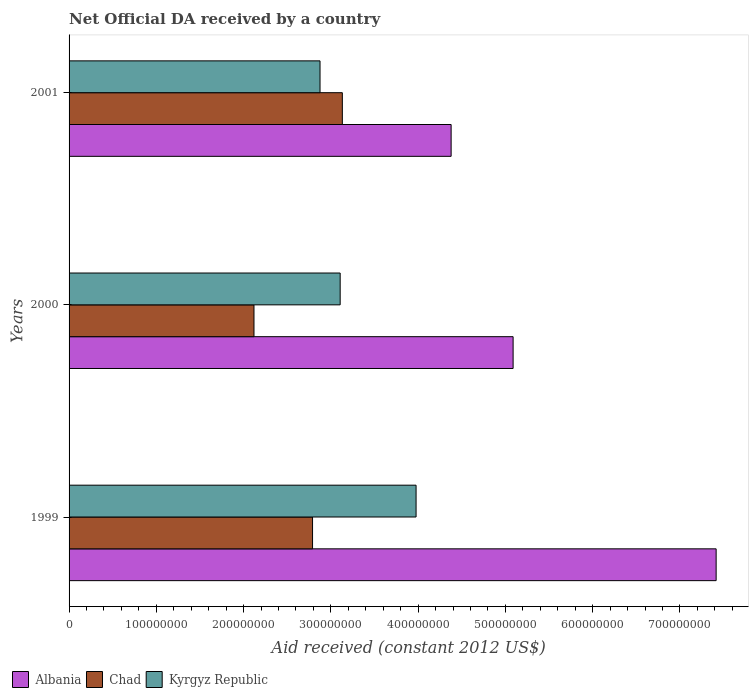How many different coloured bars are there?
Make the answer very short. 3. Are the number of bars per tick equal to the number of legend labels?
Ensure brevity in your answer.  Yes. Are the number of bars on each tick of the Y-axis equal?
Give a very brief answer. Yes. How many bars are there on the 1st tick from the bottom?
Offer a very short reply. 3. What is the net official development assistance aid received in Kyrgyz Republic in 2001?
Offer a terse response. 2.88e+08. Across all years, what is the maximum net official development assistance aid received in Albania?
Make the answer very short. 7.41e+08. Across all years, what is the minimum net official development assistance aid received in Kyrgyz Republic?
Ensure brevity in your answer.  2.88e+08. In which year was the net official development assistance aid received in Albania maximum?
Your response must be concise. 1999. In which year was the net official development assistance aid received in Albania minimum?
Your response must be concise. 2001. What is the total net official development assistance aid received in Albania in the graph?
Provide a succinct answer. 1.69e+09. What is the difference between the net official development assistance aid received in Chad in 1999 and that in 2001?
Your answer should be very brief. -3.41e+07. What is the difference between the net official development assistance aid received in Albania in 2000 and the net official development assistance aid received in Kyrgyz Republic in 2001?
Offer a very short reply. 2.21e+08. What is the average net official development assistance aid received in Kyrgyz Republic per year?
Your answer should be very brief. 3.32e+08. In the year 2000, what is the difference between the net official development assistance aid received in Albania and net official development assistance aid received in Kyrgyz Republic?
Offer a terse response. 1.98e+08. What is the ratio of the net official development assistance aid received in Kyrgyz Republic in 1999 to that in 2001?
Make the answer very short. 1.38. Is the difference between the net official development assistance aid received in Albania in 1999 and 2000 greater than the difference between the net official development assistance aid received in Kyrgyz Republic in 1999 and 2000?
Give a very brief answer. Yes. What is the difference between the highest and the second highest net official development assistance aid received in Kyrgyz Republic?
Give a very brief answer. 8.70e+07. What is the difference between the highest and the lowest net official development assistance aid received in Chad?
Offer a very short reply. 1.01e+08. In how many years, is the net official development assistance aid received in Chad greater than the average net official development assistance aid received in Chad taken over all years?
Provide a short and direct response. 2. Is the sum of the net official development assistance aid received in Albania in 2000 and 2001 greater than the maximum net official development assistance aid received in Chad across all years?
Keep it short and to the point. Yes. What does the 3rd bar from the top in 1999 represents?
Ensure brevity in your answer.  Albania. What does the 3rd bar from the bottom in 1999 represents?
Provide a short and direct response. Kyrgyz Republic. How many bars are there?
Give a very brief answer. 9. Are all the bars in the graph horizontal?
Your response must be concise. Yes. How many years are there in the graph?
Offer a very short reply. 3. Are the values on the major ticks of X-axis written in scientific E-notation?
Provide a short and direct response. No. How many legend labels are there?
Provide a short and direct response. 3. How are the legend labels stacked?
Your response must be concise. Horizontal. What is the title of the graph?
Offer a very short reply. Net Official DA received by a country. Does "Slovenia" appear as one of the legend labels in the graph?
Keep it short and to the point. No. What is the label or title of the X-axis?
Give a very brief answer. Aid received (constant 2012 US$). What is the Aid received (constant 2012 US$) in Albania in 1999?
Give a very brief answer. 7.41e+08. What is the Aid received (constant 2012 US$) of Chad in 1999?
Provide a short and direct response. 2.79e+08. What is the Aid received (constant 2012 US$) in Kyrgyz Republic in 1999?
Your response must be concise. 3.98e+08. What is the Aid received (constant 2012 US$) in Albania in 2000?
Your answer should be very brief. 5.09e+08. What is the Aid received (constant 2012 US$) in Chad in 2000?
Make the answer very short. 2.12e+08. What is the Aid received (constant 2012 US$) of Kyrgyz Republic in 2000?
Your response must be concise. 3.11e+08. What is the Aid received (constant 2012 US$) in Albania in 2001?
Ensure brevity in your answer.  4.38e+08. What is the Aid received (constant 2012 US$) of Chad in 2001?
Make the answer very short. 3.13e+08. What is the Aid received (constant 2012 US$) in Kyrgyz Republic in 2001?
Make the answer very short. 2.88e+08. Across all years, what is the maximum Aid received (constant 2012 US$) in Albania?
Ensure brevity in your answer.  7.41e+08. Across all years, what is the maximum Aid received (constant 2012 US$) of Chad?
Offer a terse response. 3.13e+08. Across all years, what is the maximum Aid received (constant 2012 US$) of Kyrgyz Republic?
Offer a very short reply. 3.98e+08. Across all years, what is the minimum Aid received (constant 2012 US$) of Albania?
Your answer should be very brief. 4.38e+08. Across all years, what is the minimum Aid received (constant 2012 US$) in Chad?
Offer a very short reply. 2.12e+08. Across all years, what is the minimum Aid received (constant 2012 US$) in Kyrgyz Republic?
Offer a very short reply. 2.88e+08. What is the total Aid received (constant 2012 US$) in Albania in the graph?
Keep it short and to the point. 1.69e+09. What is the total Aid received (constant 2012 US$) in Chad in the graph?
Provide a succinct answer. 8.04e+08. What is the total Aid received (constant 2012 US$) of Kyrgyz Republic in the graph?
Make the answer very short. 9.96e+08. What is the difference between the Aid received (constant 2012 US$) in Albania in 1999 and that in 2000?
Make the answer very short. 2.33e+08. What is the difference between the Aid received (constant 2012 US$) of Chad in 1999 and that in 2000?
Keep it short and to the point. 6.71e+07. What is the difference between the Aid received (constant 2012 US$) of Kyrgyz Republic in 1999 and that in 2000?
Give a very brief answer. 8.70e+07. What is the difference between the Aid received (constant 2012 US$) in Albania in 1999 and that in 2001?
Provide a succinct answer. 3.04e+08. What is the difference between the Aid received (constant 2012 US$) of Chad in 1999 and that in 2001?
Your answer should be compact. -3.41e+07. What is the difference between the Aid received (constant 2012 US$) in Kyrgyz Republic in 1999 and that in 2001?
Your response must be concise. 1.10e+08. What is the difference between the Aid received (constant 2012 US$) in Albania in 2000 and that in 2001?
Provide a short and direct response. 7.10e+07. What is the difference between the Aid received (constant 2012 US$) of Chad in 2000 and that in 2001?
Make the answer very short. -1.01e+08. What is the difference between the Aid received (constant 2012 US$) in Kyrgyz Republic in 2000 and that in 2001?
Make the answer very short. 2.31e+07. What is the difference between the Aid received (constant 2012 US$) of Albania in 1999 and the Aid received (constant 2012 US$) of Chad in 2000?
Your answer should be compact. 5.30e+08. What is the difference between the Aid received (constant 2012 US$) of Albania in 1999 and the Aid received (constant 2012 US$) of Kyrgyz Republic in 2000?
Provide a succinct answer. 4.31e+08. What is the difference between the Aid received (constant 2012 US$) of Chad in 1999 and the Aid received (constant 2012 US$) of Kyrgyz Republic in 2000?
Your response must be concise. -3.17e+07. What is the difference between the Aid received (constant 2012 US$) of Albania in 1999 and the Aid received (constant 2012 US$) of Chad in 2001?
Your response must be concise. 4.28e+08. What is the difference between the Aid received (constant 2012 US$) of Albania in 1999 and the Aid received (constant 2012 US$) of Kyrgyz Republic in 2001?
Keep it short and to the point. 4.54e+08. What is the difference between the Aid received (constant 2012 US$) in Chad in 1999 and the Aid received (constant 2012 US$) in Kyrgyz Republic in 2001?
Keep it short and to the point. -8.57e+06. What is the difference between the Aid received (constant 2012 US$) of Albania in 2000 and the Aid received (constant 2012 US$) of Chad in 2001?
Keep it short and to the point. 1.96e+08. What is the difference between the Aid received (constant 2012 US$) in Albania in 2000 and the Aid received (constant 2012 US$) in Kyrgyz Republic in 2001?
Offer a very short reply. 2.21e+08. What is the difference between the Aid received (constant 2012 US$) in Chad in 2000 and the Aid received (constant 2012 US$) in Kyrgyz Republic in 2001?
Provide a succinct answer. -7.57e+07. What is the average Aid received (constant 2012 US$) of Albania per year?
Provide a succinct answer. 5.63e+08. What is the average Aid received (constant 2012 US$) in Chad per year?
Keep it short and to the point. 2.68e+08. What is the average Aid received (constant 2012 US$) of Kyrgyz Republic per year?
Provide a succinct answer. 3.32e+08. In the year 1999, what is the difference between the Aid received (constant 2012 US$) of Albania and Aid received (constant 2012 US$) of Chad?
Your answer should be very brief. 4.62e+08. In the year 1999, what is the difference between the Aid received (constant 2012 US$) in Albania and Aid received (constant 2012 US$) in Kyrgyz Republic?
Make the answer very short. 3.44e+08. In the year 1999, what is the difference between the Aid received (constant 2012 US$) of Chad and Aid received (constant 2012 US$) of Kyrgyz Republic?
Offer a very short reply. -1.19e+08. In the year 2000, what is the difference between the Aid received (constant 2012 US$) of Albania and Aid received (constant 2012 US$) of Chad?
Make the answer very short. 2.97e+08. In the year 2000, what is the difference between the Aid received (constant 2012 US$) of Albania and Aid received (constant 2012 US$) of Kyrgyz Republic?
Make the answer very short. 1.98e+08. In the year 2000, what is the difference between the Aid received (constant 2012 US$) of Chad and Aid received (constant 2012 US$) of Kyrgyz Republic?
Make the answer very short. -9.88e+07. In the year 2001, what is the difference between the Aid received (constant 2012 US$) of Albania and Aid received (constant 2012 US$) of Chad?
Keep it short and to the point. 1.25e+08. In the year 2001, what is the difference between the Aid received (constant 2012 US$) in Albania and Aid received (constant 2012 US$) in Kyrgyz Republic?
Keep it short and to the point. 1.50e+08. In the year 2001, what is the difference between the Aid received (constant 2012 US$) of Chad and Aid received (constant 2012 US$) of Kyrgyz Republic?
Your answer should be compact. 2.56e+07. What is the ratio of the Aid received (constant 2012 US$) in Albania in 1999 to that in 2000?
Keep it short and to the point. 1.46. What is the ratio of the Aid received (constant 2012 US$) in Chad in 1999 to that in 2000?
Make the answer very short. 1.32. What is the ratio of the Aid received (constant 2012 US$) in Kyrgyz Republic in 1999 to that in 2000?
Make the answer very short. 1.28. What is the ratio of the Aid received (constant 2012 US$) of Albania in 1999 to that in 2001?
Your answer should be very brief. 1.69. What is the ratio of the Aid received (constant 2012 US$) of Chad in 1999 to that in 2001?
Offer a terse response. 0.89. What is the ratio of the Aid received (constant 2012 US$) of Kyrgyz Republic in 1999 to that in 2001?
Keep it short and to the point. 1.38. What is the ratio of the Aid received (constant 2012 US$) of Albania in 2000 to that in 2001?
Offer a very short reply. 1.16. What is the ratio of the Aid received (constant 2012 US$) in Chad in 2000 to that in 2001?
Your response must be concise. 0.68. What is the ratio of the Aid received (constant 2012 US$) of Kyrgyz Republic in 2000 to that in 2001?
Ensure brevity in your answer.  1.08. What is the difference between the highest and the second highest Aid received (constant 2012 US$) of Albania?
Your answer should be very brief. 2.33e+08. What is the difference between the highest and the second highest Aid received (constant 2012 US$) of Chad?
Make the answer very short. 3.41e+07. What is the difference between the highest and the second highest Aid received (constant 2012 US$) in Kyrgyz Republic?
Provide a succinct answer. 8.70e+07. What is the difference between the highest and the lowest Aid received (constant 2012 US$) of Albania?
Offer a terse response. 3.04e+08. What is the difference between the highest and the lowest Aid received (constant 2012 US$) of Chad?
Offer a terse response. 1.01e+08. What is the difference between the highest and the lowest Aid received (constant 2012 US$) in Kyrgyz Republic?
Offer a terse response. 1.10e+08. 